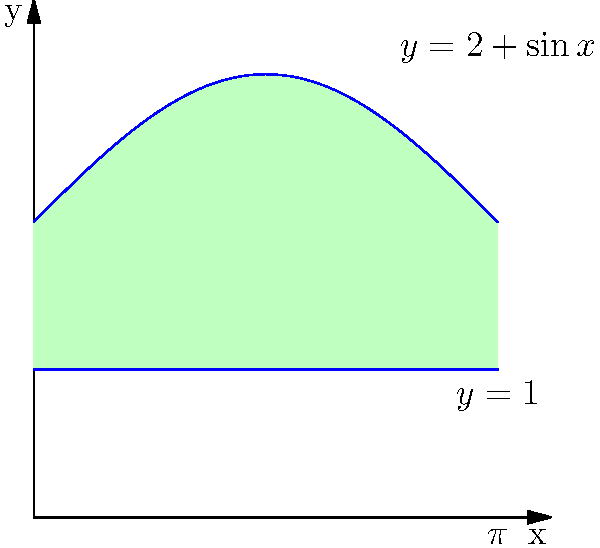As a contemporary literature author, you're designing a unique bookstore display stand for your latest novel. The cross-sectional area of the stand is modeled by the region bounded by the curves $y = 2 + \sin x$, $y = 1$, and the y-axis, from $x = 0$ to $x = \pi$. If the stand extends to a depth of 3 feet, what is its volume in cubic feet? To find the volume of the bookstore display stand, we need to follow these steps:

1) First, we need to find the area of the cross-section. This is given by the integral of the difference between the upper and lower functions from 0 to $\pi$:

   $$A = \int_0^\pi [(2 + \sin x) - 1] dx = \int_0^\pi (1 + \sin x) dx$$

2) Let's evaluate this integral:
   $$A = [x - \cos x]_0^\pi = (\pi - \cos \pi) - (0 - \cos 0) = \pi - (-1) - 1 = \pi + 2$$

3) Now that we have the area of the cross-section, we can find the volume by multiplying this area by the depth of the stand:

   $$V = A \cdot \text{depth} = (\pi + 2) \cdot 3$$

4) Simplify:
   $$V = 3\pi + 6 \approx 15.42 \text{ cubic feet}$$

Thus, the volume of the bookstore display stand is $3\pi + 6$ cubic feet.
Answer: $3\pi + 6$ cubic feet 